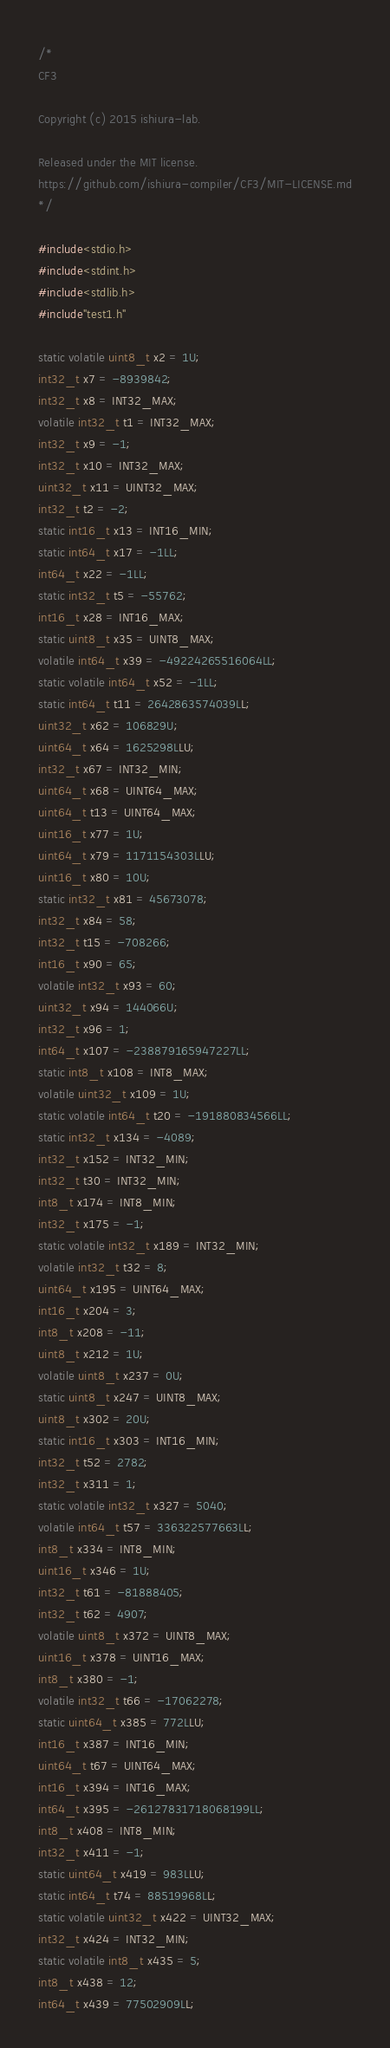<code> <loc_0><loc_0><loc_500><loc_500><_C_>
/*
CF3

Copyright (c) 2015 ishiura-lab.

Released under the MIT license.  
https://github.com/ishiura-compiler/CF3/MIT-LICENSE.md
*/

#include<stdio.h>
#include<stdint.h>
#include<stdlib.h>
#include"test1.h"

static volatile uint8_t x2 = 1U;
int32_t x7 = -8939842;
int32_t x8 = INT32_MAX;
volatile int32_t t1 = INT32_MAX;
int32_t x9 = -1;
int32_t x10 = INT32_MAX;
uint32_t x11 = UINT32_MAX;
int32_t t2 = -2;
static int16_t x13 = INT16_MIN;
static int64_t x17 = -1LL;
int64_t x22 = -1LL;
static int32_t t5 = -55762;
int16_t x28 = INT16_MAX;
static uint8_t x35 = UINT8_MAX;
volatile int64_t x39 = -49224265516064LL;
static volatile int64_t x52 = -1LL;
static int64_t t11 = 2642863574039LL;
uint32_t x62 = 106829U;
uint64_t x64 = 1625298LLU;
int32_t x67 = INT32_MIN;
uint64_t x68 = UINT64_MAX;
uint64_t t13 = UINT64_MAX;
uint16_t x77 = 1U;
uint64_t x79 = 1171154303LLU;
uint16_t x80 = 10U;
static int32_t x81 = 45673078;
int32_t x84 = 58;
int32_t t15 = -708266;
int16_t x90 = 65;
volatile int32_t x93 = 60;
uint32_t x94 = 144066U;
int32_t x96 = 1;
int64_t x107 = -238879165947227LL;
static int8_t x108 = INT8_MAX;
volatile uint32_t x109 = 1U;
static volatile int64_t t20 = -191880834566LL;
static int32_t x134 = -4089;
int32_t x152 = INT32_MIN;
int32_t t30 = INT32_MIN;
int8_t x174 = INT8_MIN;
int32_t x175 = -1;
static volatile int32_t x189 = INT32_MIN;
volatile int32_t t32 = 8;
uint64_t x195 = UINT64_MAX;
int16_t x204 = 3;
int8_t x208 = -11;
uint8_t x212 = 1U;
volatile uint8_t x237 = 0U;
static uint8_t x247 = UINT8_MAX;
uint8_t x302 = 20U;
static int16_t x303 = INT16_MIN;
int32_t t52 = 2782;
int32_t x311 = 1;
static volatile int32_t x327 = 5040;
volatile int64_t t57 = 336322577663LL;
int8_t x334 = INT8_MIN;
uint16_t x346 = 1U;
int32_t t61 = -81888405;
int32_t t62 = 4907;
volatile uint8_t x372 = UINT8_MAX;
uint16_t x378 = UINT16_MAX;
int8_t x380 = -1;
volatile int32_t t66 = -17062278;
static uint64_t x385 = 772LLU;
int16_t x387 = INT16_MIN;
uint64_t t67 = UINT64_MAX;
int16_t x394 = INT16_MAX;
int64_t x395 = -26127831718068199LL;
int8_t x408 = INT8_MIN;
int32_t x411 = -1;
static uint64_t x419 = 983LLU;
static int64_t t74 = 88519968LL;
static volatile uint32_t x422 = UINT32_MAX;
int32_t x424 = INT32_MIN;
static volatile int8_t x435 = 5;
int8_t x438 = 12;
int64_t x439 = 77502909LL;</code> 